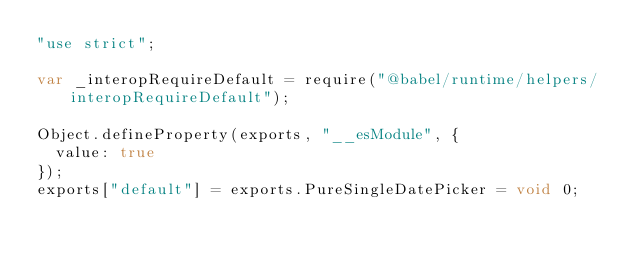<code> <loc_0><loc_0><loc_500><loc_500><_JavaScript_>"use strict";

var _interopRequireDefault = require("@babel/runtime/helpers/interopRequireDefault");

Object.defineProperty(exports, "__esModule", {
  value: true
});
exports["default"] = exports.PureSingleDatePicker = void 0;
</code> 